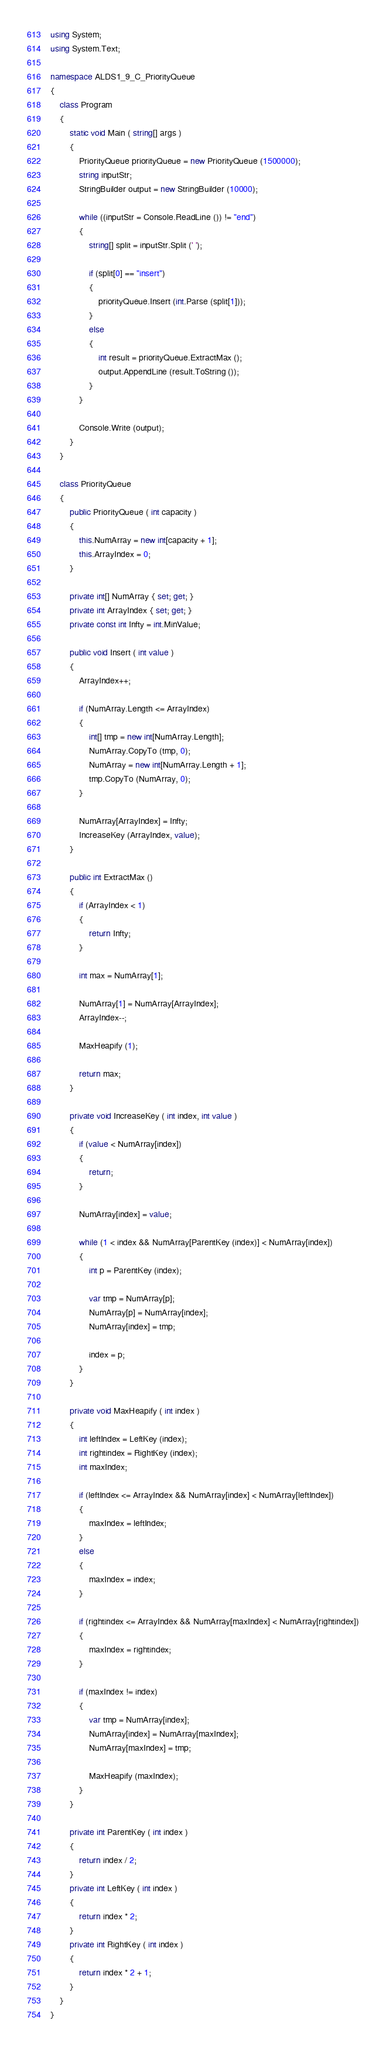<code> <loc_0><loc_0><loc_500><loc_500><_C#_>using System;
using System.Text;

namespace ALDS1_9_C_PriorityQueue
{
	class Program
	{
		static void Main ( string[] args )
		{
			PriorityQueue priorityQueue = new PriorityQueue (1500000);
			string inputStr;
			StringBuilder output = new StringBuilder (10000);

			while ((inputStr = Console.ReadLine ()) != "end")
			{
				string[] split = inputStr.Split (' ');

				if (split[0] == "insert")
				{
					priorityQueue.Insert (int.Parse (split[1]));
				}
				else
				{
					int result = priorityQueue.ExtractMax ();
					output.AppendLine (result.ToString ());
				}
			}

			Console.Write (output);
		}
	}

	class PriorityQueue
	{
		public PriorityQueue ( int capacity )
		{
			this.NumArray = new int[capacity + 1];
			this.ArrayIndex = 0;
		}

		private int[] NumArray { set; get; }
		private int ArrayIndex { set; get; }
		private const int Infty = int.MinValue;

		public void Insert ( int value )
		{
			ArrayIndex++;

			if (NumArray.Length <= ArrayIndex)
			{
				int[] tmp = new int[NumArray.Length];
				NumArray.CopyTo (tmp, 0);
				NumArray = new int[NumArray.Length + 1];
				tmp.CopyTo (NumArray, 0);
			}

			NumArray[ArrayIndex] = Infty;
			IncreaseKey (ArrayIndex, value);
		}

		public int ExtractMax ()
		{
			if (ArrayIndex < 1)
			{
				return Infty;
			}

			int max = NumArray[1];

			NumArray[1] = NumArray[ArrayIndex];
			ArrayIndex--;

			MaxHeapify (1);

			return max;
		}

		private void IncreaseKey ( int index, int value )
		{
			if (value < NumArray[index])
			{
				return;
			}

			NumArray[index] = value;

			while (1 < index && NumArray[ParentKey (index)] < NumArray[index])
			{
				int p = ParentKey (index);

				var tmp = NumArray[p];
				NumArray[p] = NumArray[index];
				NumArray[index] = tmp;

				index = p;
			}
		}

		private void MaxHeapify ( int index )
		{
			int leftIndex = LeftKey (index);
			int rightindex = RightKey (index);
			int maxIndex;

			if (leftIndex <= ArrayIndex && NumArray[index] < NumArray[leftIndex])
			{
				maxIndex = leftIndex;
			}
			else
			{
				maxIndex = index;
			}

			if (rightindex <= ArrayIndex && NumArray[maxIndex] < NumArray[rightindex])
			{
				maxIndex = rightindex;
			}

			if (maxIndex != index)
			{
				var tmp = NumArray[index];
				NumArray[index] = NumArray[maxIndex];
				NumArray[maxIndex] = tmp;

				MaxHeapify (maxIndex);
			}
		}

		private int ParentKey ( int index )
		{
			return index / 2;
		}
		private int LeftKey ( int index )
		{
			return index * 2;
		}
		private int RightKey ( int index )
		{
			return index * 2 + 1;
		}
	}
}</code> 